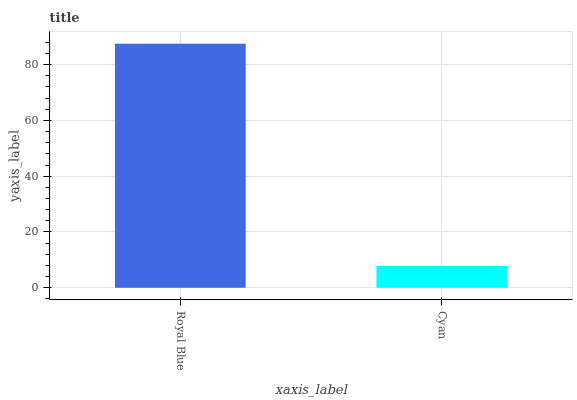Is Cyan the minimum?
Answer yes or no. Yes. Is Royal Blue the maximum?
Answer yes or no. Yes. Is Cyan the maximum?
Answer yes or no. No. Is Royal Blue greater than Cyan?
Answer yes or no. Yes. Is Cyan less than Royal Blue?
Answer yes or no. Yes. Is Cyan greater than Royal Blue?
Answer yes or no. No. Is Royal Blue less than Cyan?
Answer yes or no. No. Is Royal Blue the high median?
Answer yes or no. Yes. Is Cyan the low median?
Answer yes or no. Yes. Is Cyan the high median?
Answer yes or no. No. Is Royal Blue the low median?
Answer yes or no. No. 